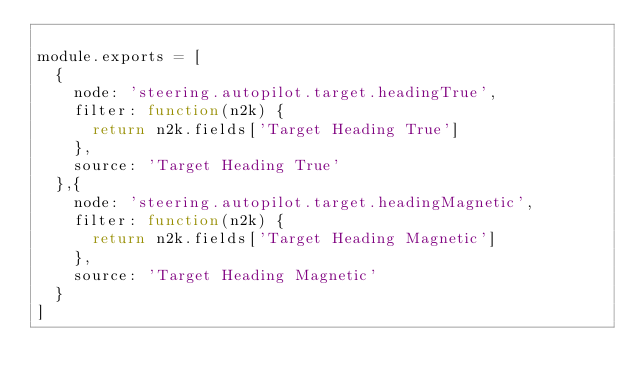<code> <loc_0><loc_0><loc_500><loc_500><_JavaScript_>
module.exports = [
  {
    node: 'steering.autopilot.target.headingTrue',
    filter: function(n2k) {
      return n2k.fields['Target Heading True']
    },
    source: 'Target Heading True'
  },{
    node: 'steering.autopilot.target.headingMagnetic',
    filter: function(n2k) {
      return n2k.fields['Target Heading Magnetic']
    },
    source: 'Target Heading Magnetic'
  }
]
</code> 